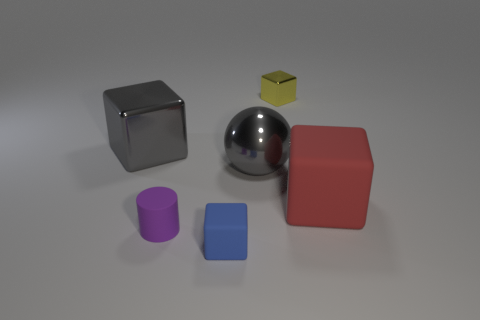Add 3 large red matte objects. How many objects exist? 9 Subtract all balls. How many objects are left? 5 Add 1 tiny purple cylinders. How many tiny purple cylinders are left? 2 Add 6 large brown metal blocks. How many large brown metal blocks exist? 6 Subtract 1 gray spheres. How many objects are left? 5 Subtract all balls. Subtract all large red matte cubes. How many objects are left? 4 